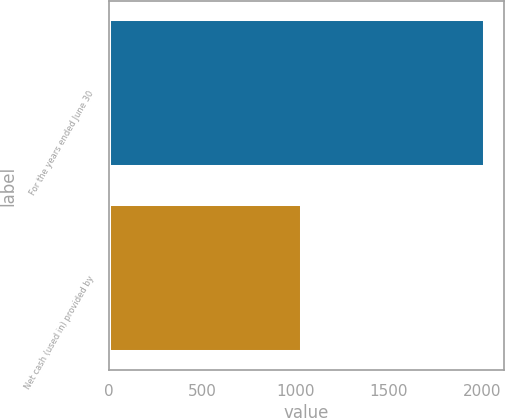Convert chart. <chart><loc_0><loc_0><loc_500><loc_500><bar_chart><fcel>For the years ended June 30<fcel>Net cash (used in) provided by<nl><fcel>2018<fcel>1036<nl></chart> 